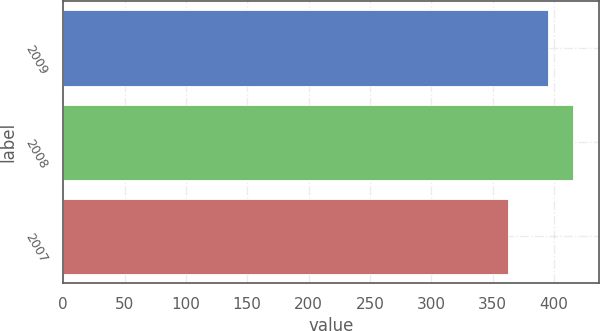Convert chart to OTSL. <chart><loc_0><loc_0><loc_500><loc_500><bar_chart><fcel>2009<fcel>2008<fcel>2007<nl><fcel>395<fcel>416<fcel>363<nl></chart> 